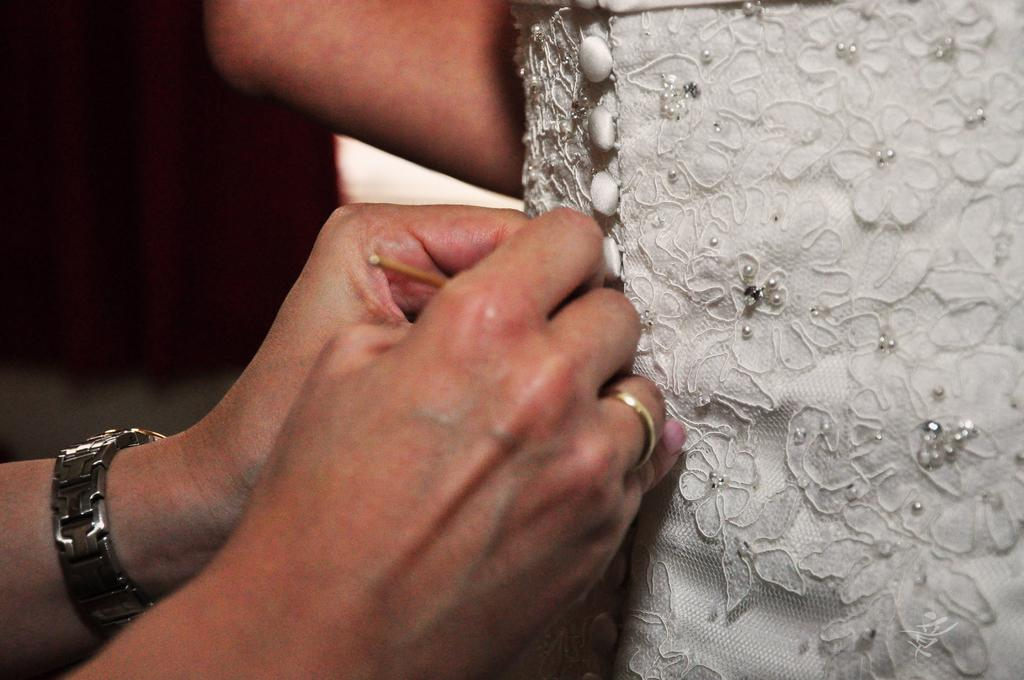What is the main subject in the foreground of the image? There is a person in the foreground of the image on the right side. What can be seen on the left side of the image? There are two hands of a person on the left side of the image. What is on one of the hands? A watch is present on one of the hands. What type of leather is the frog using to jump in the image? There is no frog present in the image, and therefore no such activity can be observed. 